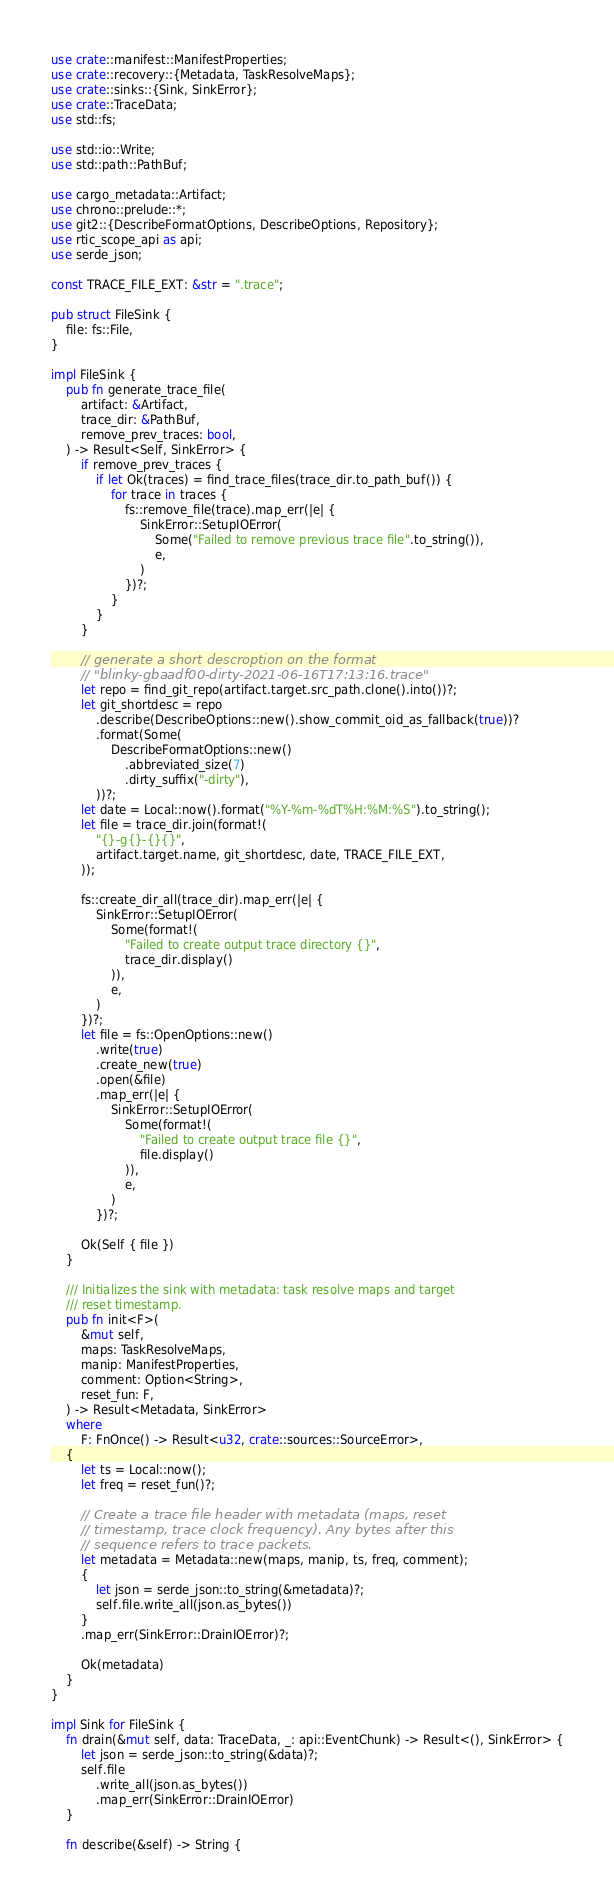Convert code to text. <code><loc_0><loc_0><loc_500><loc_500><_Rust_>use crate::manifest::ManifestProperties;
use crate::recovery::{Metadata, TaskResolveMaps};
use crate::sinks::{Sink, SinkError};
use crate::TraceData;
use std::fs;

use std::io::Write;
use std::path::PathBuf;

use cargo_metadata::Artifact;
use chrono::prelude::*;
use git2::{DescribeFormatOptions, DescribeOptions, Repository};
use rtic_scope_api as api;
use serde_json;

const TRACE_FILE_EXT: &str = ".trace";

pub struct FileSink {
    file: fs::File,
}

impl FileSink {
    pub fn generate_trace_file(
        artifact: &Artifact,
        trace_dir: &PathBuf,
        remove_prev_traces: bool,
    ) -> Result<Self, SinkError> {
        if remove_prev_traces {
            if let Ok(traces) = find_trace_files(trace_dir.to_path_buf()) {
                for trace in traces {
                    fs::remove_file(trace).map_err(|e| {
                        SinkError::SetupIOError(
                            Some("Failed to remove previous trace file".to_string()),
                            e,
                        )
                    })?;
                }
            }
        }

        // generate a short descroption on the format
        // "blinky-gbaadf00-dirty-2021-06-16T17:13:16.trace"
        let repo = find_git_repo(artifact.target.src_path.clone().into())?;
        let git_shortdesc = repo
            .describe(DescribeOptions::new().show_commit_oid_as_fallback(true))?
            .format(Some(
                DescribeFormatOptions::new()
                    .abbreviated_size(7)
                    .dirty_suffix("-dirty"),
            ))?;
        let date = Local::now().format("%Y-%m-%dT%H:%M:%S").to_string();
        let file = trace_dir.join(format!(
            "{}-g{}-{}{}",
            artifact.target.name, git_shortdesc, date, TRACE_FILE_EXT,
        ));

        fs::create_dir_all(trace_dir).map_err(|e| {
            SinkError::SetupIOError(
                Some(format!(
                    "Failed to create output trace directory {}",
                    trace_dir.display()
                )),
                e,
            )
        })?;
        let file = fs::OpenOptions::new()
            .write(true)
            .create_new(true)
            .open(&file)
            .map_err(|e| {
                SinkError::SetupIOError(
                    Some(format!(
                        "Failed to create output trace file {}",
                        file.display()
                    )),
                    e,
                )
            })?;

        Ok(Self { file })
    }

    /// Initializes the sink with metadata: task resolve maps and target
    /// reset timestamp.
    pub fn init<F>(
        &mut self,
        maps: TaskResolveMaps,
        manip: ManifestProperties,
        comment: Option<String>,
        reset_fun: F,
    ) -> Result<Metadata, SinkError>
    where
        F: FnOnce() -> Result<u32, crate::sources::SourceError>,
    {
        let ts = Local::now();
        let freq = reset_fun()?;

        // Create a trace file header with metadata (maps, reset
        // timestamp, trace clock frequency). Any bytes after this
        // sequence refers to trace packets.
        let metadata = Metadata::new(maps, manip, ts, freq, comment);
        {
            let json = serde_json::to_string(&metadata)?;
            self.file.write_all(json.as_bytes())
        }
        .map_err(SinkError::DrainIOError)?;

        Ok(metadata)
    }
}

impl Sink for FileSink {
    fn drain(&mut self, data: TraceData, _: api::EventChunk) -> Result<(), SinkError> {
        let json = serde_json::to_string(&data)?;
        self.file
            .write_all(json.as_bytes())
            .map_err(SinkError::DrainIOError)
    }

    fn describe(&self) -> String {</code> 